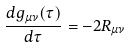<formula> <loc_0><loc_0><loc_500><loc_500>\frac { d g _ { \mu \nu } ( \tau ) } { d \tau } = - 2 R _ { \mu \nu }</formula> 